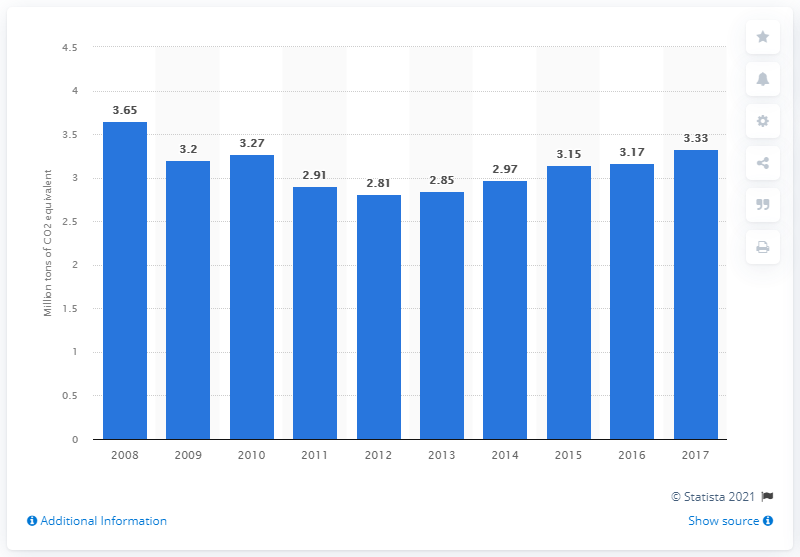Specify some key components in this picture. In 2017, the amount of CO2 equivalent produced by fuel combustion in Latvia was 3.33... 